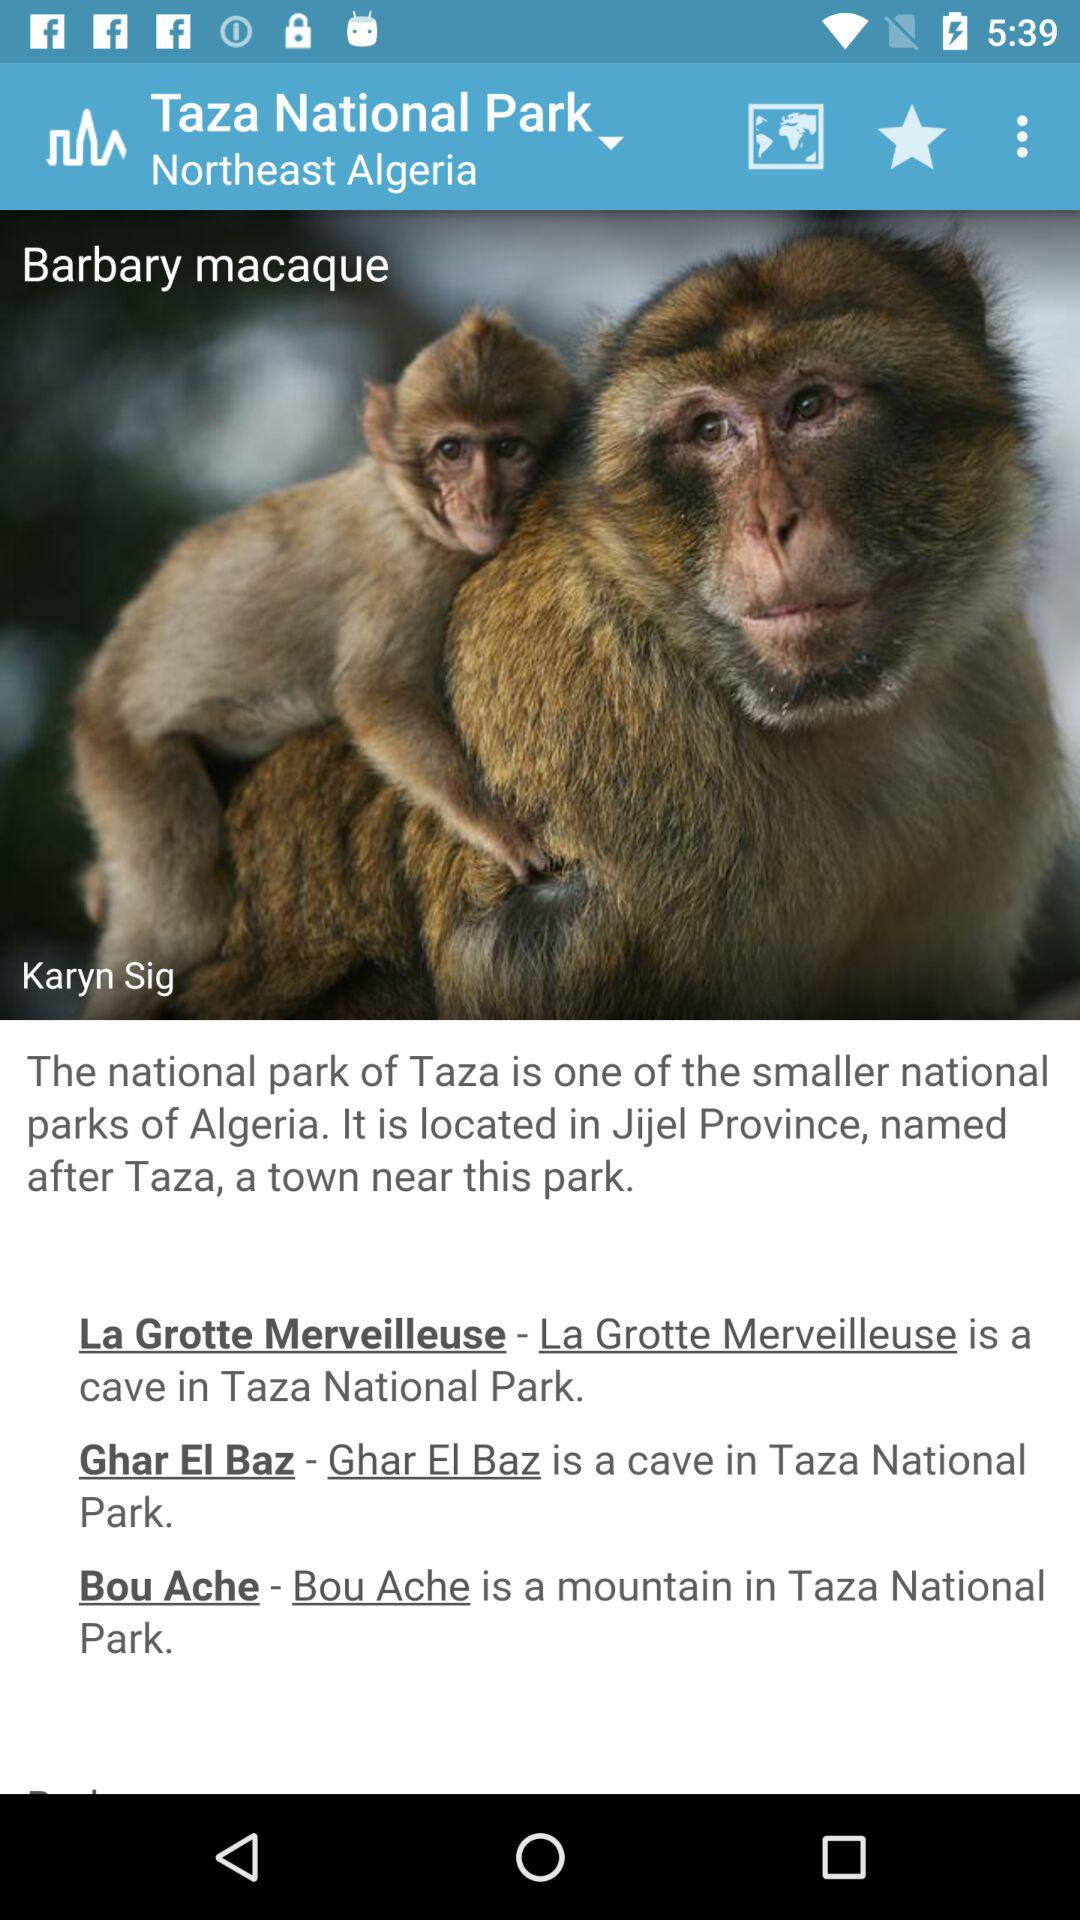What is the name of the cave in "Taza National Park"? The names of the caves in "Taza National Park" are "La Grotte Merveilleuse" and "Ghar El Baz". 